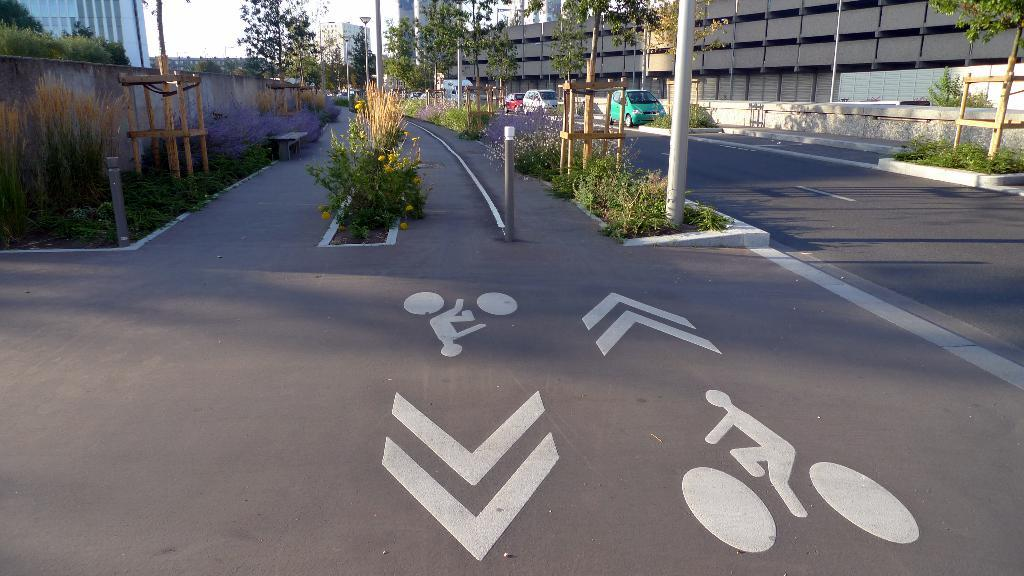What is located in the middle of the image? There are plants and poles in the middle of the image. What can be seen on the road in the image? There are vehicles on the road in the image. What is visible behind the plants, poles, and vehicles? There is a wall visible behind them. What is located behind the wall? There are buildings and trees visible behind the wall. Can you tell me how many chess pieces are on the wall in the image? There are no chess pieces present on the wall in the image. What type of scissors can be seen cutting the plants in the image? There are no scissors visible in the image, and the plants are not being cut. 